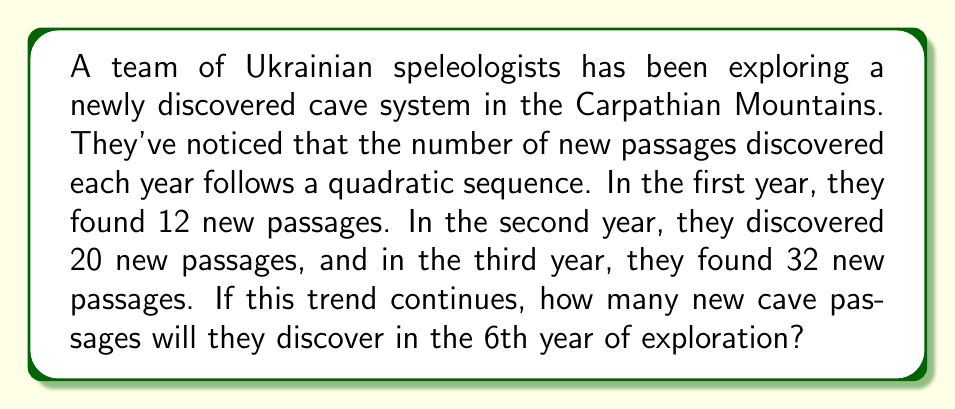Can you answer this question? Let's approach this step-by-step:

1) First, we need to find the quadratic sequence that fits the given data. The general form of a quadratic sequence is:

   $a_n = an^2 + bn + c$

   where $n$ is the term number, and $a$, $b$, and $c$ are constants we need to determine.

2) We have three equations based on the given information:
   
   Year 1: $12 = a(1)^2 + b(1) + c$
   Year 2: $20 = a(2)^2 + b(2) + c$
   Year 3: $32 = a(3)^2 + b(3) + c$

3) Simplifying:
   
   $12 = a + b + c$
   $20 = 4a + 2b + c$
   $32 = 9a + 3b + c$

4) Subtracting the first equation from the second:
   
   $8 = 3a + b$

5) Subtracting the second equation from the third:
   
   $12 = 5a + b$

6) Subtracting the equation in step 4 from the equation in step 5:
   
   $4 = 2a$
   $a = 2$

7) Substituting this back into the equation from step 4:
   
   $8 = 3(2) + b$
   $8 = 6 + b$
   $b = 2$

8) Now we can find $c$ using the first equation:
   
   $12 = 2 + 2 + c$
   $c = 8$

9) Therefore, our quadratic sequence is:
   
   $a_n = 2n^2 + 2n + 8$

10) To find the number of passages in the 6th year, we substitute $n = 6$:

    $a_6 = 2(6)^2 + 2(6) + 8$
    $a_6 = 2(36) + 12 + 8$
    $a_6 = 72 + 12 + 8$
    $a_6 = 92$

Thus, in the 6th year, they will discover 92 new cave passages.
Answer: 92 